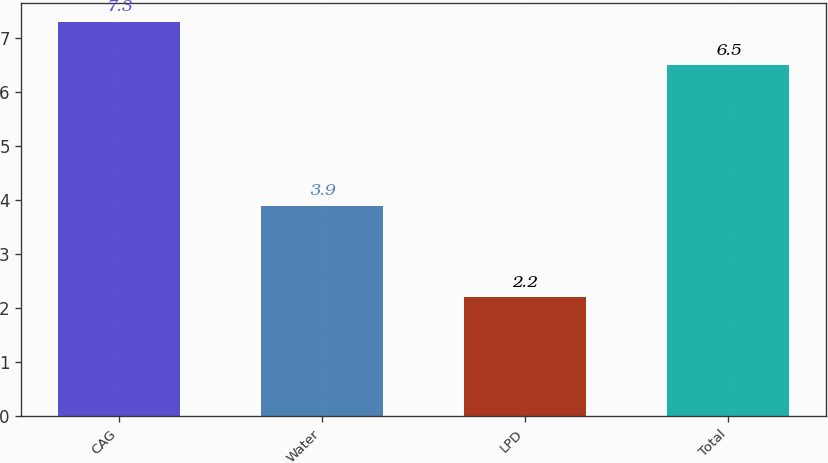<chart> <loc_0><loc_0><loc_500><loc_500><bar_chart><fcel>CAG<fcel>Water<fcel>LPD<fcel>Total<nl><fcel>7.3<fcel>3.9<fcel>2.2<fcel>6.5<nl></chart> 